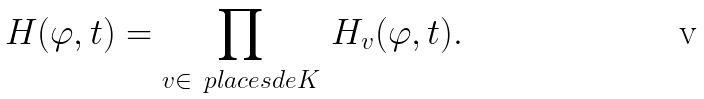Convert formula to latex. <formula><loc_0><loc_0><loc_500><loc_500>H ( \varphi , t ) = \prod _ { v \in \ p l a c e s d e { K } } \, H _ { v } ( \varphi , t ) .</formula> 